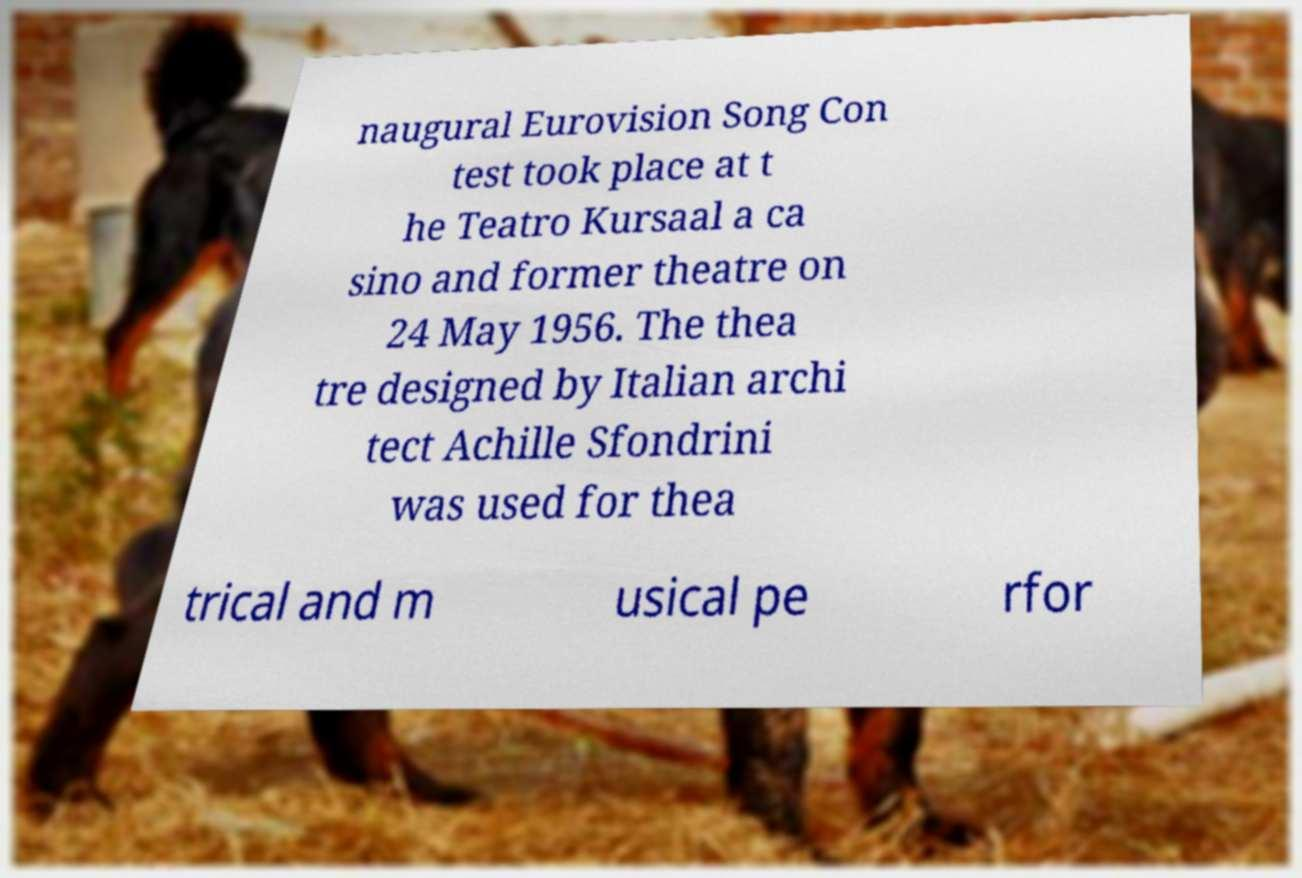Please identify and transcribe the text found in this image. naugural Eurovision Song Con test took place at t he Teatro Kursaal a ca sino and former theatre on 24 May 1956. The thea tre designed by Italian archi tect Achille Sfondrini was used for thea trical and m usical pe rfor 